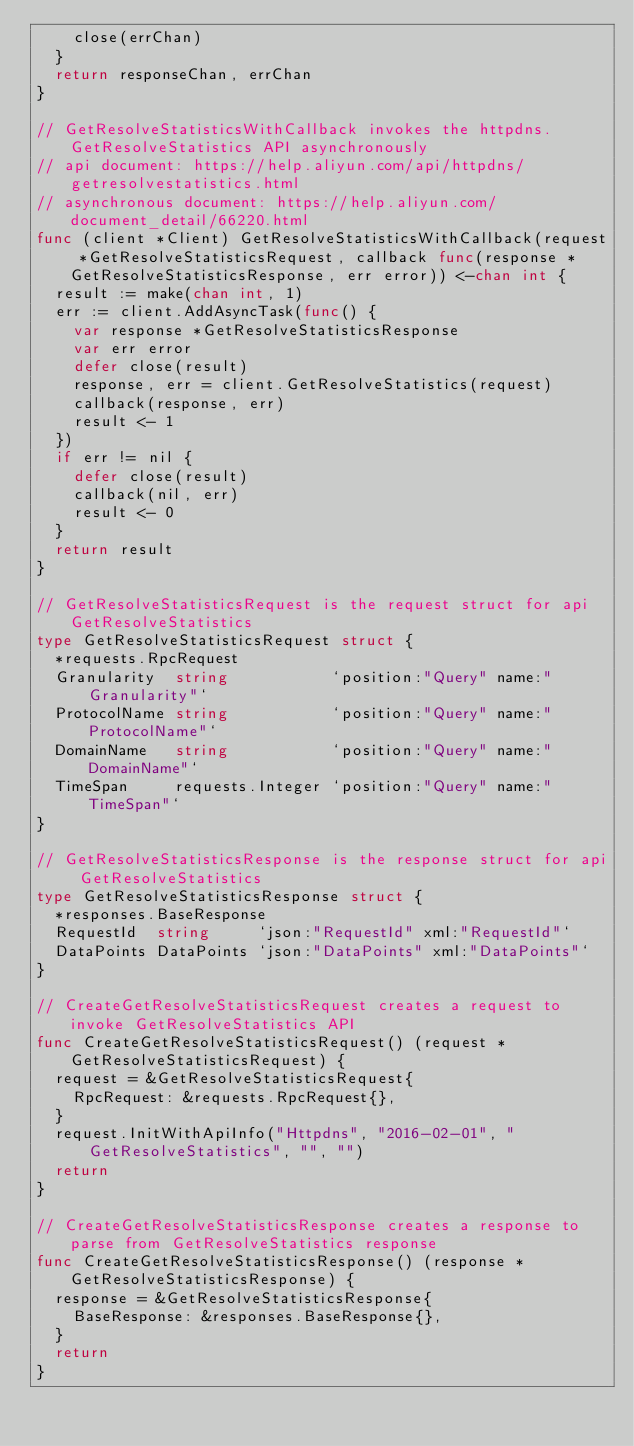<code> <loc_0><loc_0><loc_500><loc_500><_Go_>		close(errChan)
	}
	return responseChan, errChan
}

// GetResolveStatisticsWithCallback invokes the httpdns.GetResolveStatistics API asynchronously
// api document: https://help.aliyun.com/api/httpdns/getresolvestatistics.html
// asynchronous document: https://help.aliyun.com/document_detail/66220.html
func (client *Client) GetResolveStatisticsWithCallback(request *GetResolveStatisticsRequest, callback func(response *GetResolveStatisticsResponse, err error)) <-chan int {
	result := make(chan int, 1)
	err := client.AddAsyncTask(func() {
		var response *GetResolveStatisticsResponse
		var err error
		defer close(result)
		response, err = client.GetResolveStatistics(request)
		callback(response, err)
		result <- 1
	})
	if err != nil {
		defer close(result)
		callback(nil, err)
		result <- 0
	}
	return result
}

// GetResolveStatisticsRequest is the request struct for api GetResolveStatistics
type GetResolveStatisticsRequest struct {
	*requests.RpcRequest
	Granularity  string           `position:"Query" name:"Granularity"`
	ProtocolName string           `position:"Query" name:"ProtocolName"`
	DomainName   string           `position:"Query" name:"DomainName"`
	TimeSpan     requests.Integer `position:"Query" name:"TimeSpan"`
}

// GetResolveStatisticsResponse is the response struct for api GetResolveStatistics
type GetResolveStatisticsResponse struct {
	*responses.BaseResponse
	RequestId  string     `json:"RequestId" xml:"RequestId"`
	DataPoints DataPoints `json:"DataPoints" xml:"DataPoints"`
}

// CreateGetResolveStatisticsRequest creates a request to invoke GetResolveStatistics API
func CreateGetResolveStatisticsRequest() (request *GetResolveStatisticsRequest) {
	request = &GetResolveStatisticsRequest{
		RpcRequest: &requests.RpcRequest{},
	}
	request.InitWithApiInfo("Httpdns", "2016-02-01", "GetResolveStatistics", "", "")
	return
}

// CreateGetResolveStatisticsResponse creates a response to parse from GetResolveStatistics response
func CreateGetResolveStatisticsResponse() (response *GetResolveStatisticsResponse) {
	response = &GetResolveStatisticsResponse{
		BaseResponse: &responses.BaseResponse{},
	}
	return
}
</code> 